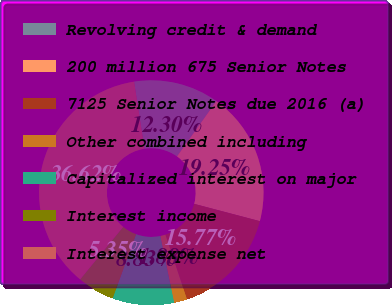Convert chart to OTSL. <chart><loc_0><loc_0><loc_500><loc_500><pie_chart><fcel>Revolving credit & demand<fcel>200 million 675 Senior Notes<fcel>7125 Senior Notes due 2016 (a)<fcel>Other combined including<fcel>Capitalized interest on major<fcel>Interest income<fcel>Interest expense net<nl><fcel>12.3%<fcel>19.25%<fcel>15.77%<fcel>1.88%<fcel>8.83%<fcel>5.35%<fcel>36.62%<nl></chart> 